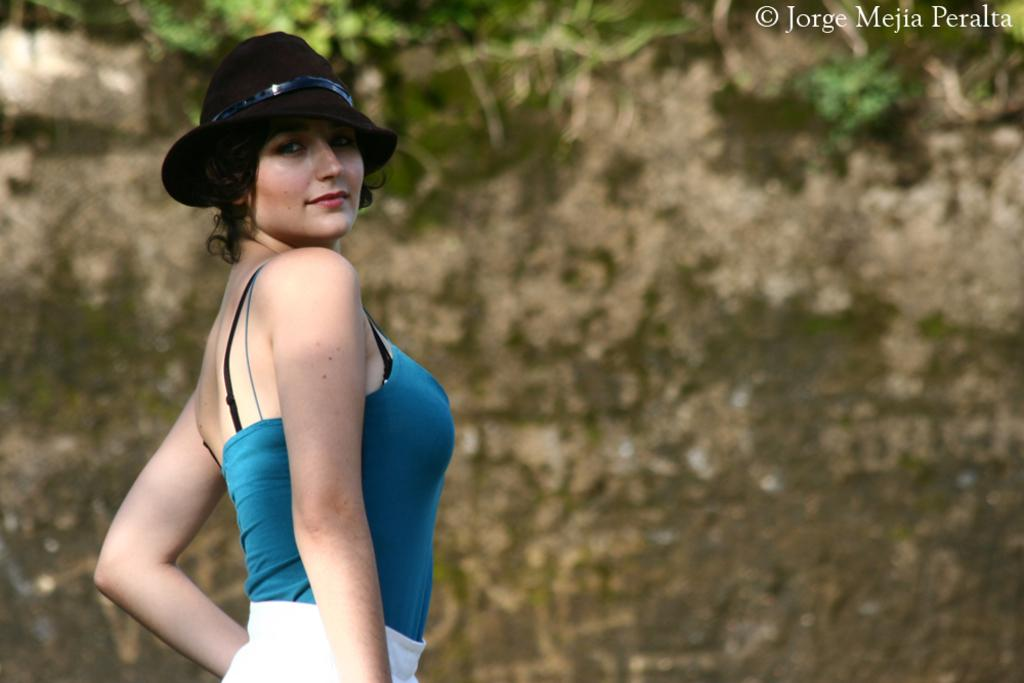Who is on the left side of the image? There is a woman on the left side of the image. What is the woman wearing on her head? The woman is wearing a hat. Can you describe the background of the image? The background of the image is blurred. What celestial bodies can be seen at the top of the image? Planets are visible at the top of the image. What type of structure can be seen in the morning in the image? There is no structure visible in the image, and the time of day is not mentioned. 